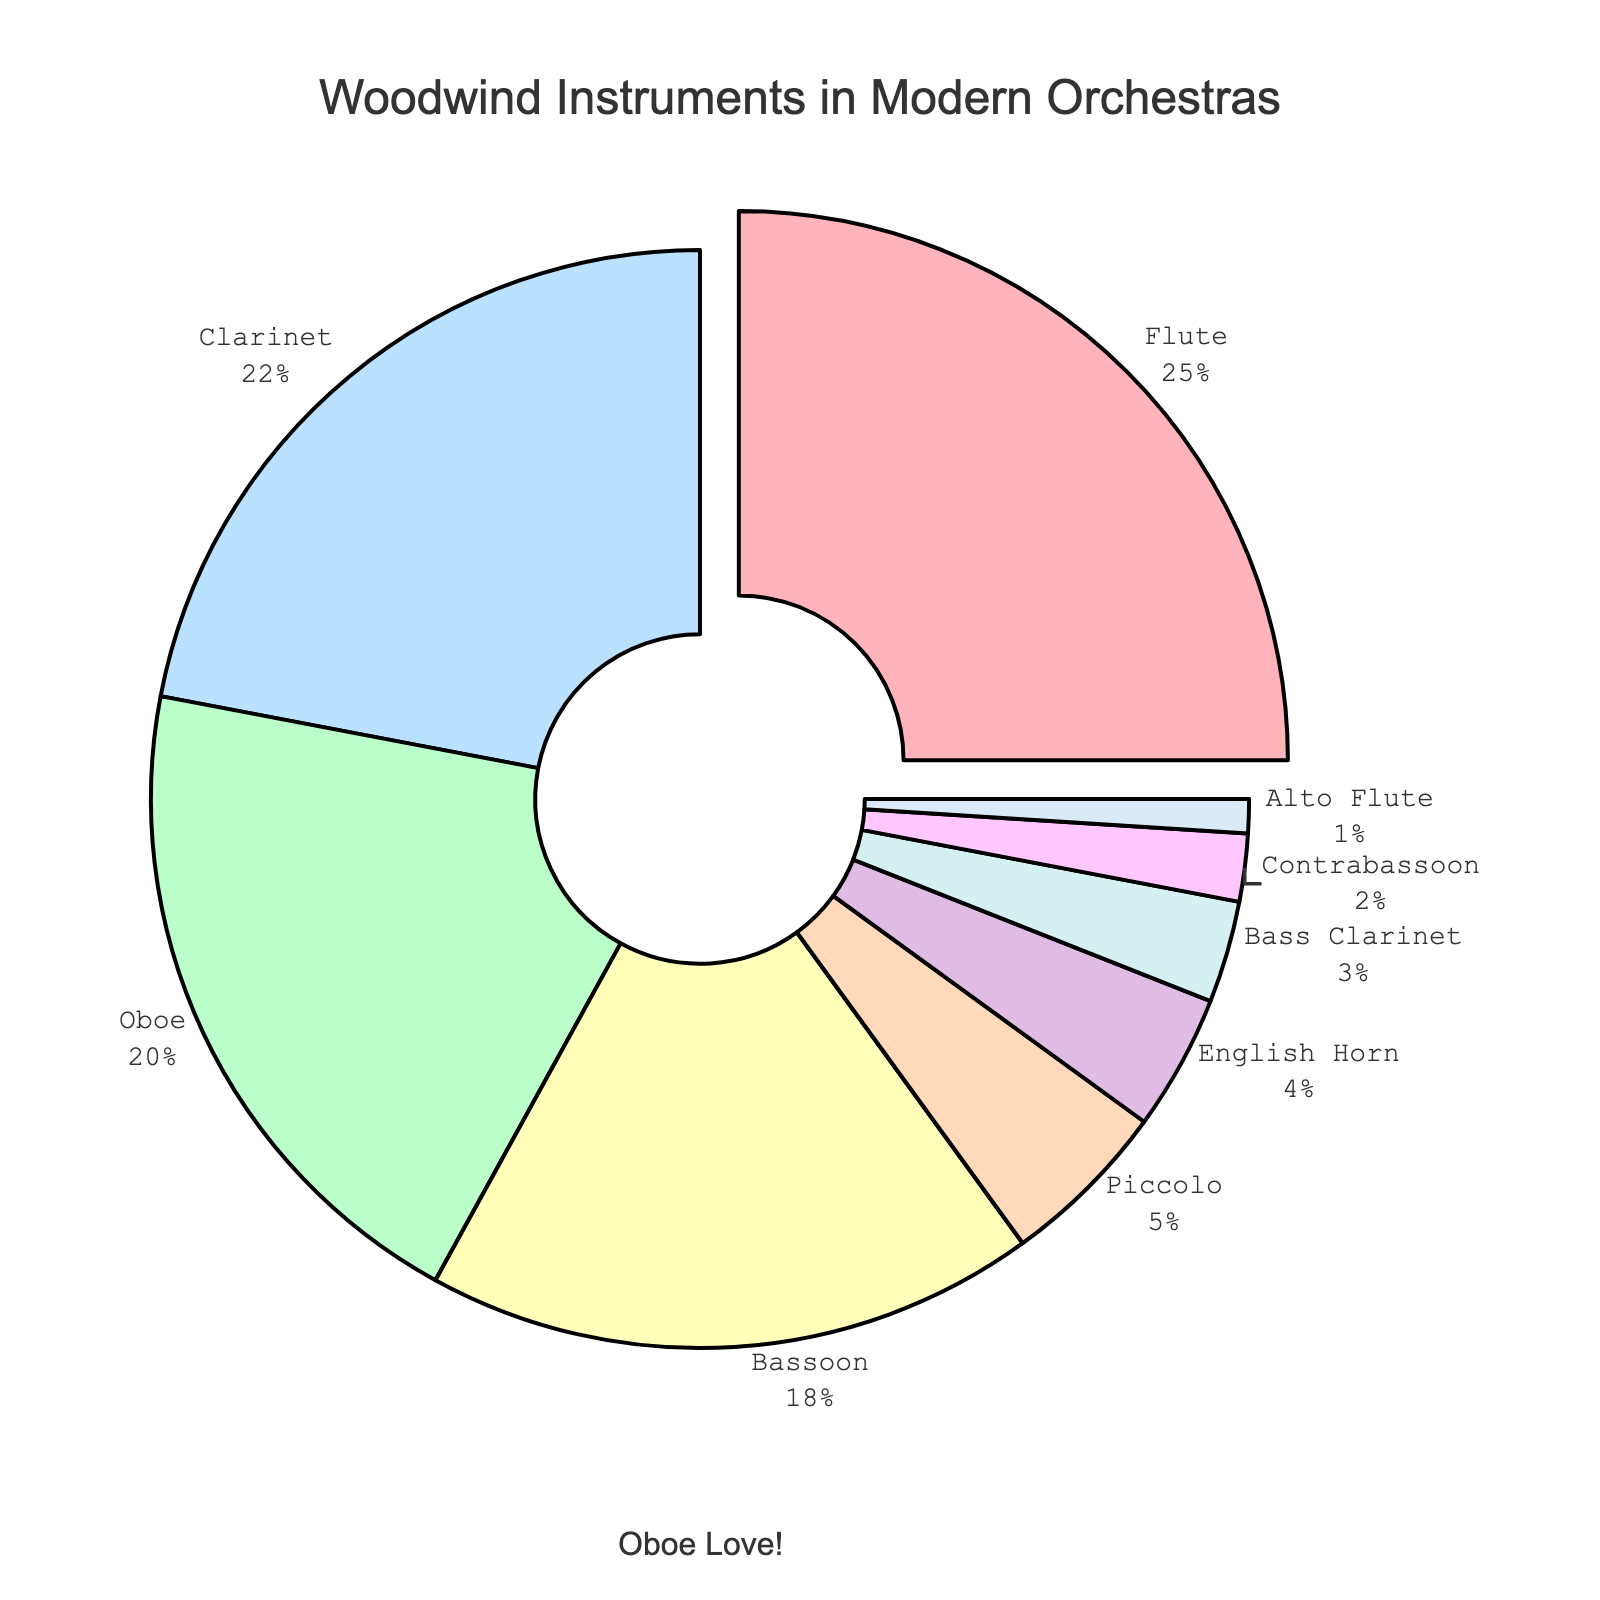Which instrument has the largest percentage? The pie chart indicates the largest section is labeled "Flute", and visually it's the biggest slice. Flute has the largest percentage.
Answer: Flute What is the total percentage of Oboe and Clarinet? Oboe has 20% and Clarinet has 22%. Adding these together, 20% + 22% = 42%.
Answer: 42% Is there any instrument that has a percentage less than 5%? If yes, name them. The chart displays several small slices, labeled Piccolo (5%), English Horn (4%), Bass Clarinet (3%), Contrabassoon (2%), and Alto Flute (1%). All of them are less than 5%.
Answer: Yes, English Horn, Bass Clarinet, Contrabassoon, Alto Flute Which is greater, the percentage of Bassoon or English Horn? The Bassoon slice is noticeably larger than the English Horn's. Bassoon has 18% and English Horn has 4%. 18% is greater than 4%.
Answer: Bassoon What is the combined percentage of all the instruments that have 5% or less? Adding up the percentages for Piccolo (5%), English Horn (4%), Bass Clarinet (3%), Contrabassoon (2%), and Alto Flute (1%) gives 5% + 4% + 3% + 2% + 1% = 15%.
Answer: 15% Which instrument is highlighted with a separation from the pie chart? The chart's visual feature shows one slice being pulled out from the rest. This slice is labeled "Flute", making it the highlighted instrument.
Answer: Flute How much more is the percentage of Clarinet than that of Piccolo? Clarinet has 22% and Piccolo has 5%. The difference is 22% - 5% = 17%.
Answer: 17% What is the average percentage of Flute, Oboe, and Clarinet combined? Flute has 25%, Oboe 20%, and Clarinet 22%. Sum these up: 25% + 20% + 22% = 67%. The average is 67% ÷ 3 = 22.33%.
Answer: 22.33% Which slice is the smallest in the chart? The chart shows a very small slice labeled "Alto Flute", which is the smallest percentage of all listed.
Answer: Alto Flute 